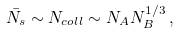<formula> <loc_0><loc_0><loc_500><loc_500>\bar { N _ { s } } \sim N _ { c o l l } \sim N _ { A } N _ { B } ^ { 1 / 3 } \, ,</formula> 